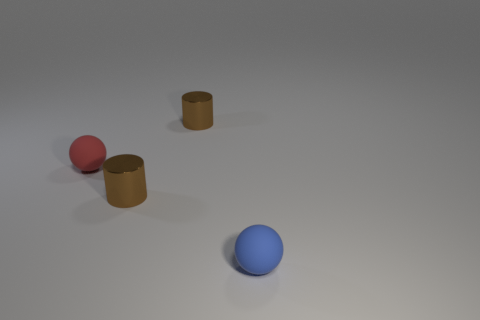What number of objects are both in front of the red sphere and left of the blue rubber thing?
Provide a short and direct response. 1. How many things are blue rubber spheres or objects that are right of the red thing?
Your response must be concise. 3. There is a tiny sphere that is behind the blue matte object; what color is it?
Offer a terse response. Red. What number of things are either matte things that are to the right of the small red matte thing or large brown things?
Offer a terse response. 1. There is a ball that is the same size as the blue object; what color is it?
Make the answer very short. Red. Are there more blue objects that are to the right of the blue matte thing than red matte objects?
Your answer should be compact. No. What is the tiny object that is in front of the red matte ball and behind the tiny blue ball made of?
Offer a terse response. Metal. There is a shiny object behind the red matte sphere; is it the same color as the shiny thing that is in front of the tiny red thing?
Keep it short and to the point. Yes. What number of other objects are there of the same size as the blue ball?
Provide a short and direct response. 3. Are there any metallic things that are behind the tiny rubber ball that is behind the small rubber sphere that is on the right side of the red ball?
Your answer should be very brief. Yes. 